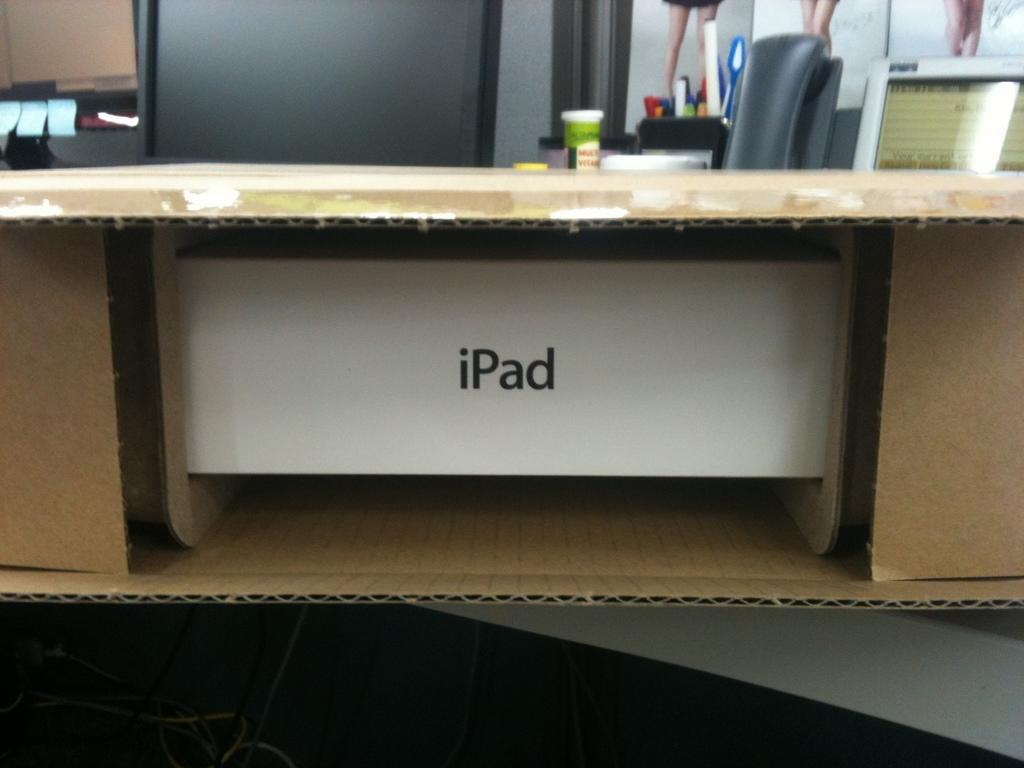In one or two sentences, can you explain what this image depicts? In the image we can see there is a cardboard box in which there is an "iPad". Behind there is a monitor and pen stand kept on the table. 